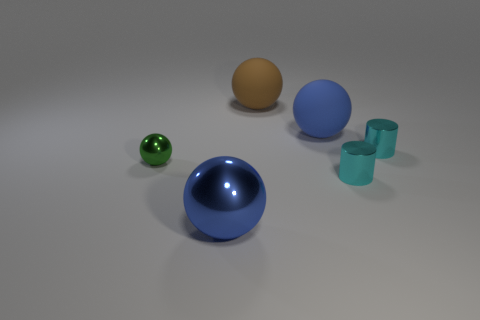There is a thing left of the blue shiny ball; what is its shape?
Your response must be concise. Sphere. The object that is in front of the green ball and behind the large metal sphere has what shape?
Provide a short and direct response. Cylinder. How many brown things are either cylinders or big metal things?
Give a very brief answer. 0. Is the color of the matte object right of the large brown rubber object the same as the big shiny sphere?
Provide a short and direct response. Yes. There is a ball that is to the left of the big blue sphere left of the brown thing; what size is it?
Make the answer very short. Small. There is another blue thing that is the same size as the blue metal thing; what material is it?
Offer a terse response. Rubber. What number of other objects are there of the same size as the blue matte object?
Provide a succinct answer. 2. What number of cylinders are big rubber things or small cyan things?
Your response must be concise. 2. What is the material of the big sphere that is in front of the blue sphere that is behind the metal ball that is on the right side of the green object?
Keep it short and to the point. Metal. What is the material of the big ball that is the same color as the big metal thing?
Your answer should be very brief. Rubber. 